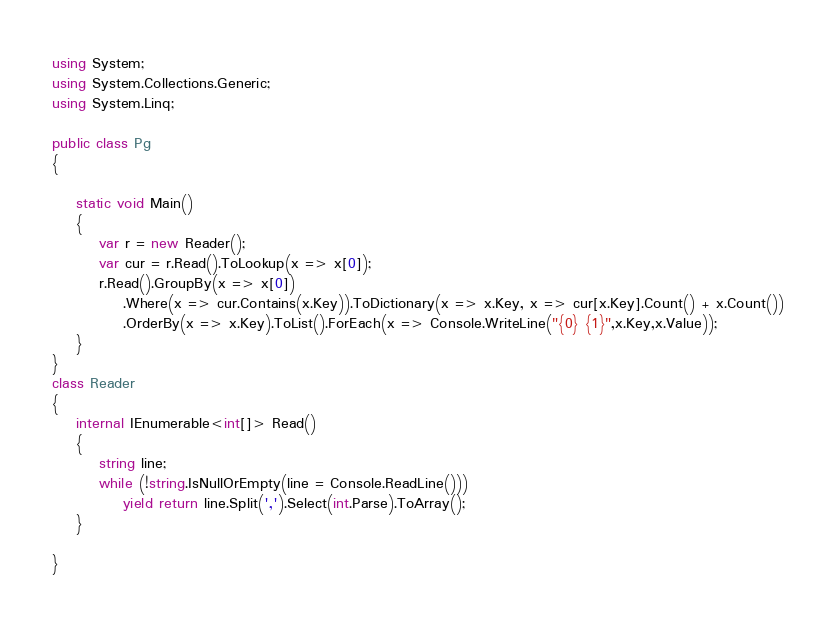Convert code to text. <code><loc_0><loc_0><loc_500><loc_500><_C#_>using System;
using System.Collections.Generic;
using System.Linq;

public class Pg
{

    static void Main()
    {
        var r = new Reader();
        var cur = r.Read().ToLookup(x => x[0]);
        r.Read().GroupBy(x => x[0])
            .Where(x => cur.Contains(x.Key)).ToDictionary(x => x.Key, x => cur[x.Key].Count() + x.Count())
            .OrderBy(x => x.Key).ToList().ForEach(x => Console.WriteLine("{0} {1}",x.Key,x.Value));
    }
}
class Reader
{
    internal IEnumerable<int[]> Read()
    {
        string line;
        while (!string.IsNullOrEmpty(line = Console.ReadLine()))
            yield return line.Split(',').Select(int.Parse).ToArray();
    }

}
</code> 